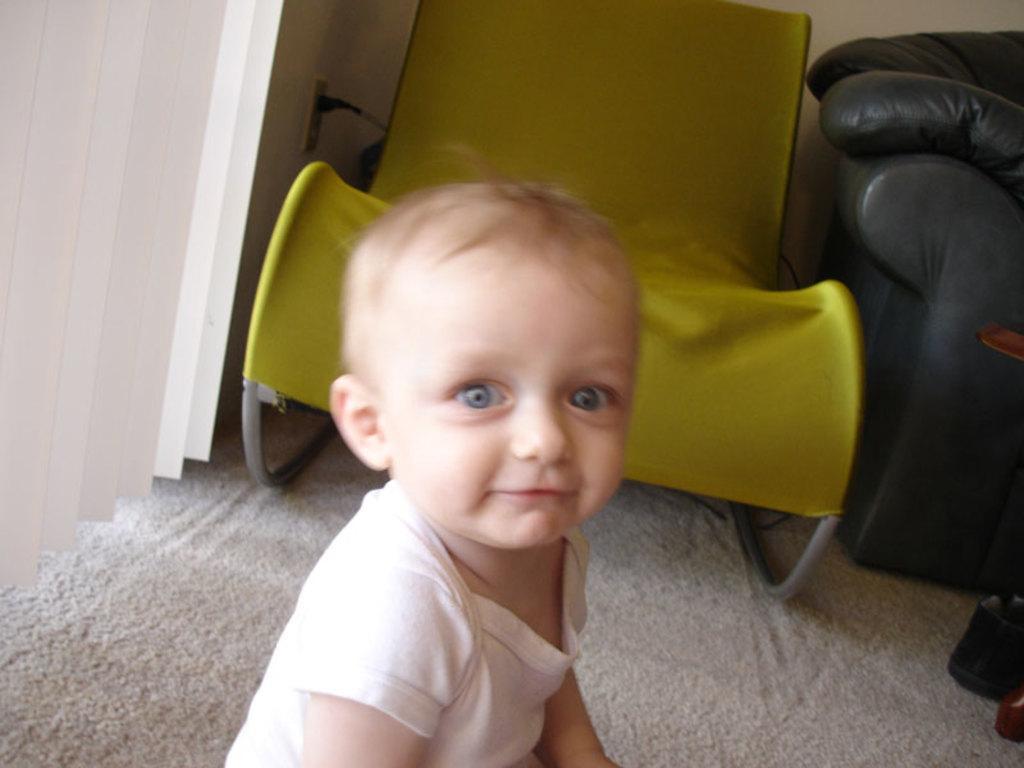In one or two sentences, can you explain what this image depicts? In the image we can see a baby wearing clothes and the baby is smiling. Here we can see the couch, rest chair, floor and the window blinds. 